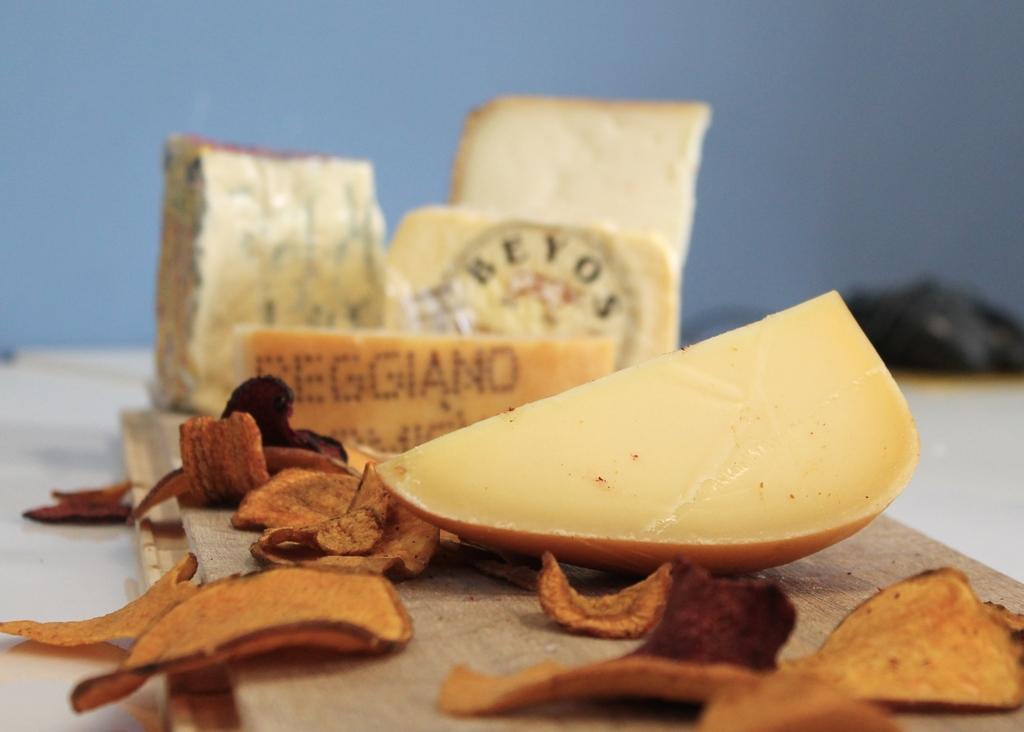How would you summarize this image in a sentence or two? In this image there are chips, there is a fruit and there is some text written which is visible and there are pieces of bread and the background is blurry. 